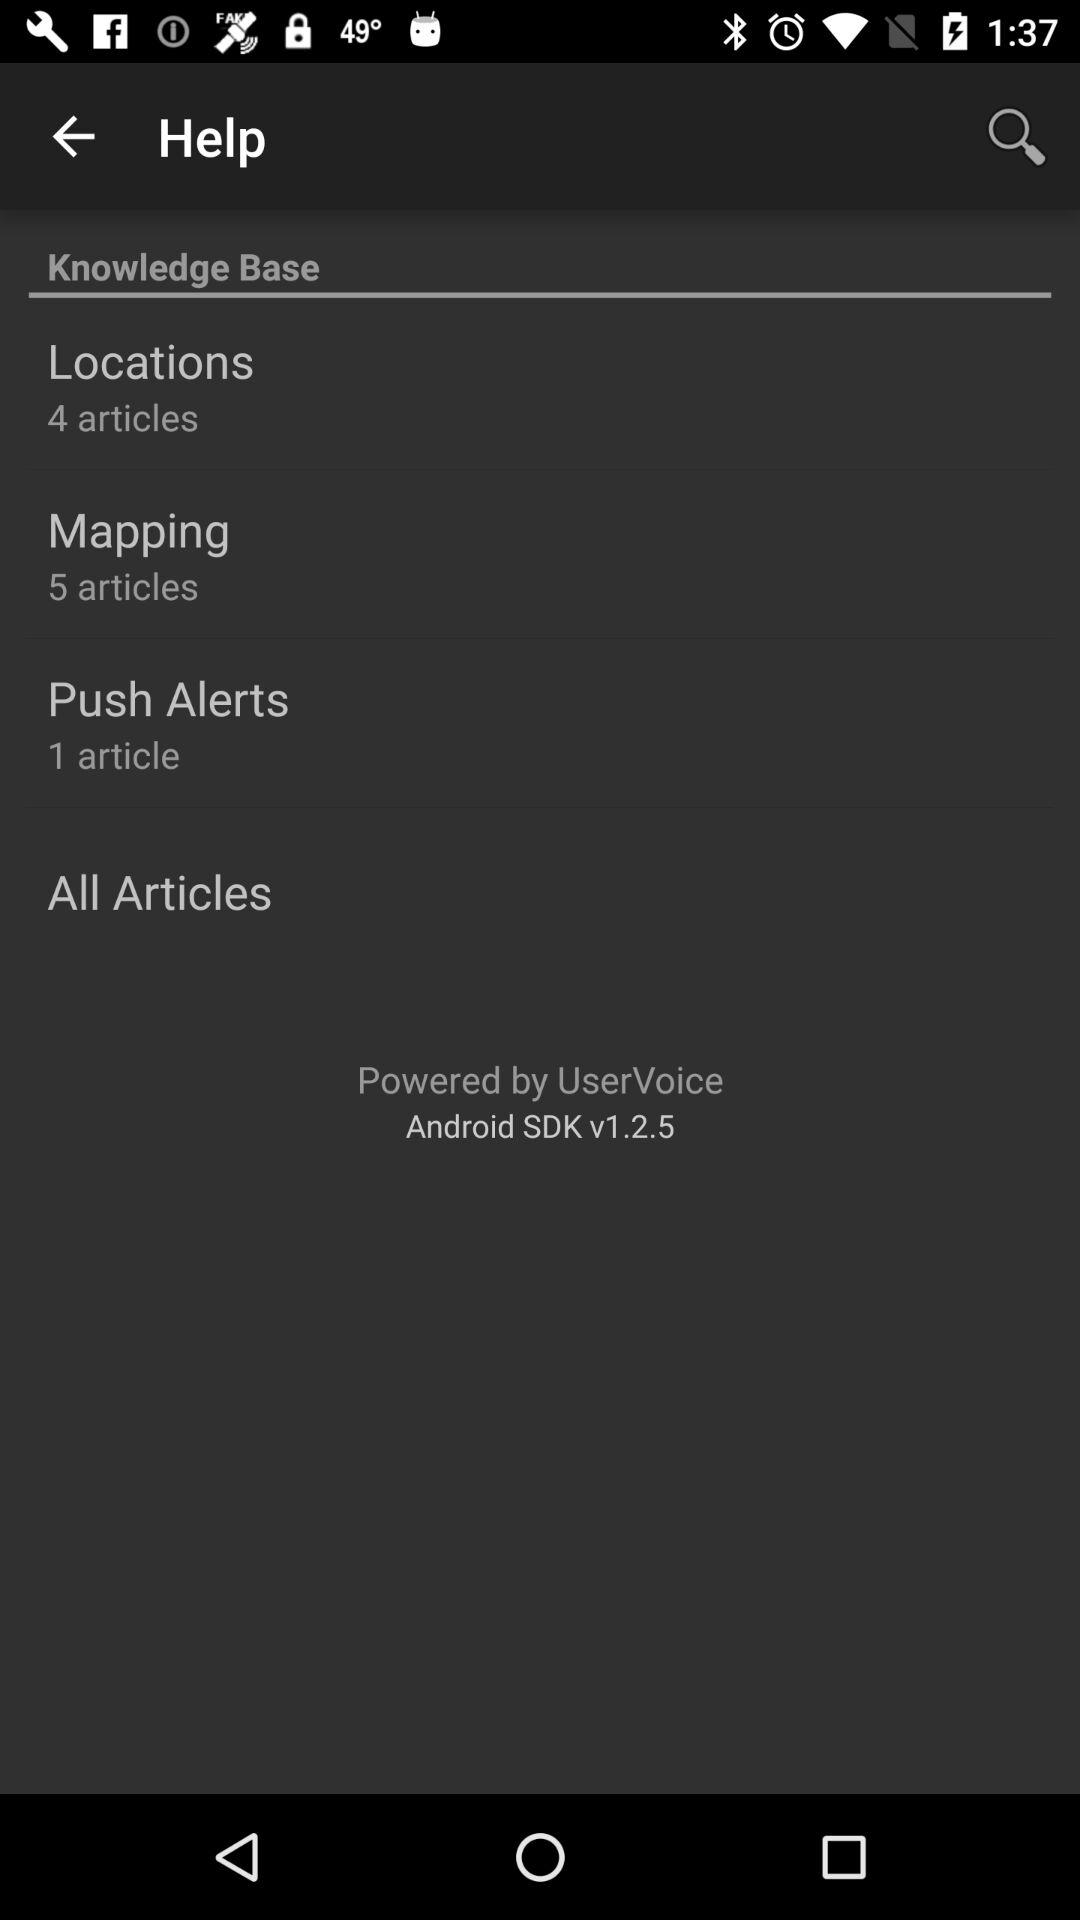What might be the function of the 'All Articles' button? The 'All Articles' button likely serves as a quick way to access the complete list of available articles within the knowledge base, regardless of their categorization into specific sections such as 'Locations' or 'Mapping.' 